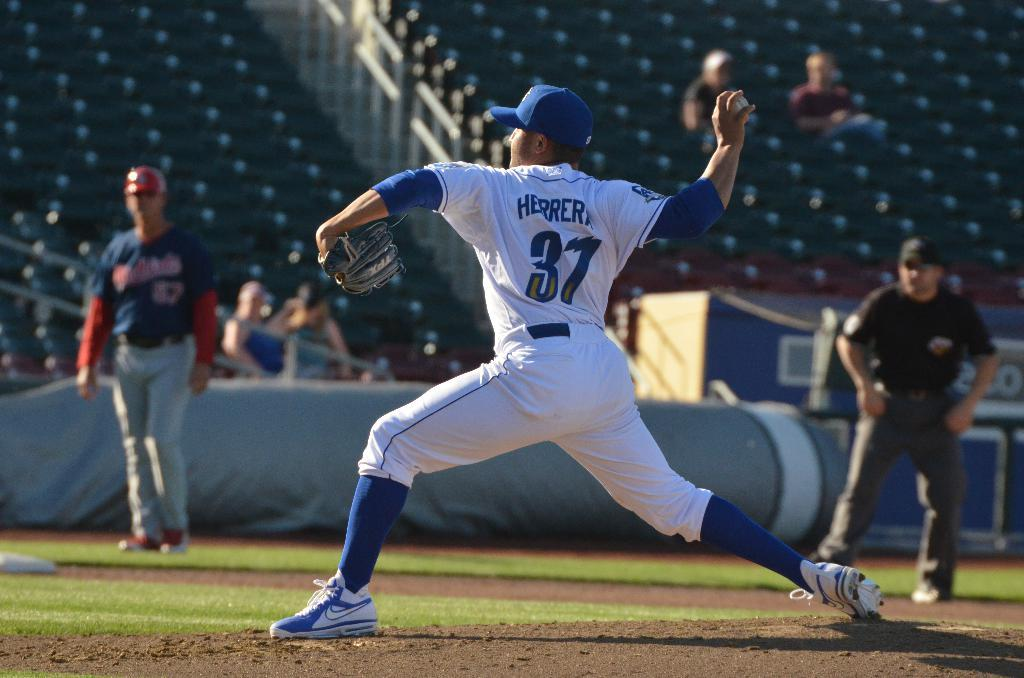<image>
Share a concise interpretation of the image provided. Number 37 in a white and blue uniform pitches the ball while the coach from the opposing team and umpire watch from the side. 